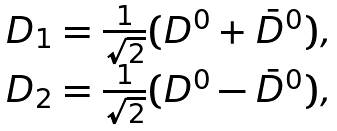Convert formula to latex. <formula><loc_0><loc_0><loc_500><loc_500>\begin{array} { l } { { D _ { 1 } = \frac { 1 } { \sqrt { 2 } } ( D ^ { 0 } + \bar { D } ^ { 0 } ) , } } \\ { { D _ { 2 } = \frac { 1 } { \sqrt { 2 } } ( D ^ { 0 } - \bar { D } ^ { 0 } ) , } } \end{array}</formula> 